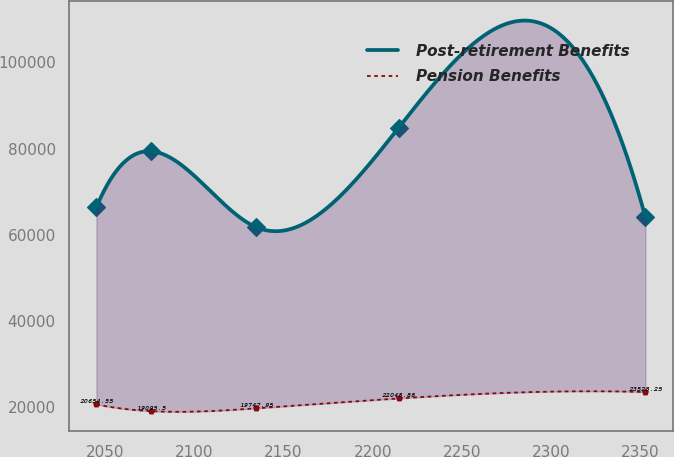<chart> <loc_0><loc_0><loc_500><loc_500><line_chart><ecel><fcel>Post-retirement Benefits<fcel>Pension Benefits<nl><fcel>2045.33<fcel>66395.7<fcel>20654.5<nl><fcel>2076.07<fcel>79356.3<fcel>19095.5<nl><fcel>2134.69<fcel>61780.9<fcel>19748<nl><fcel>2214.64<fcel>84854.9<fcel>22045.9<nl><fcel>2352.72<fcel>64088.3<fcel>23528.2<nl></chart> 